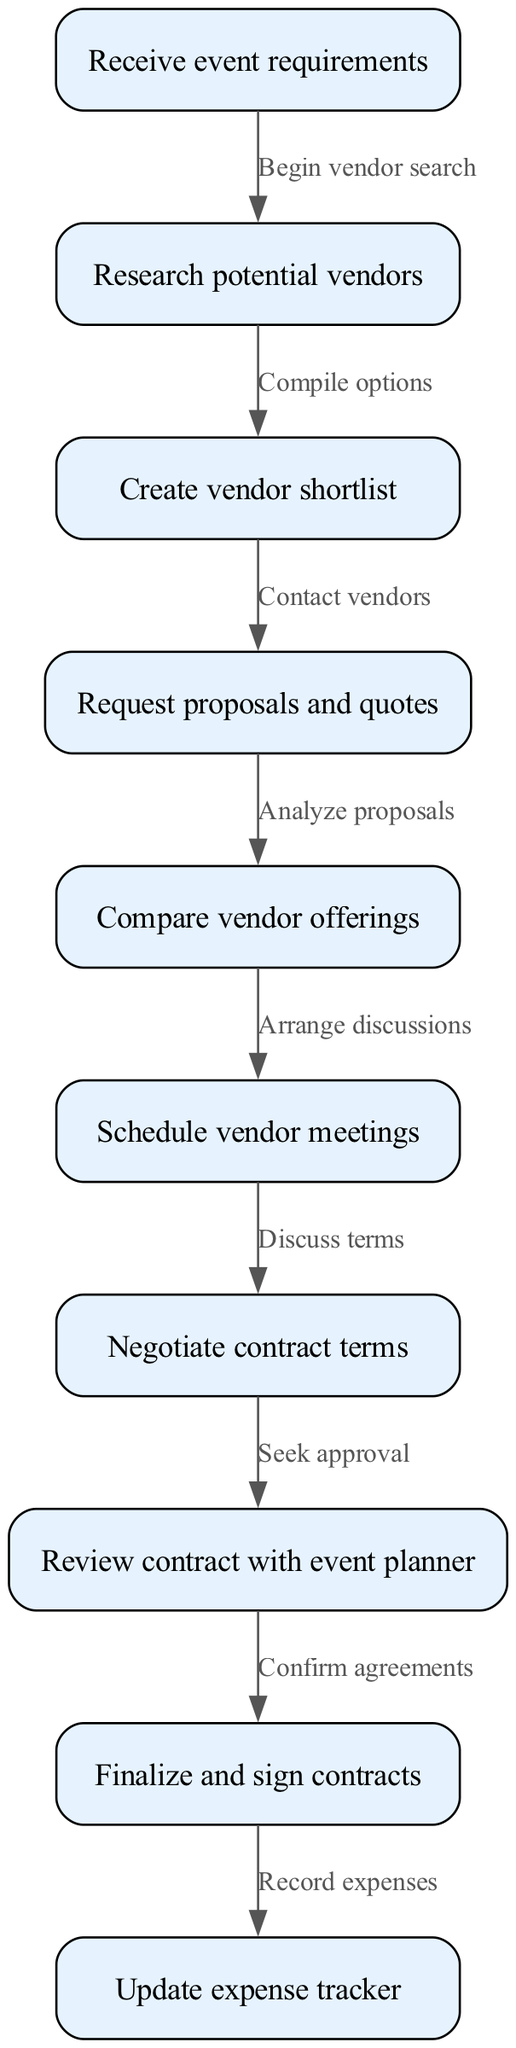What is the first step in the vendor selection workflow? The first step in the workflow is represented by the node labeled "Receive event requirements". This indicates that gathering the event specifics is the initial action before any vendor-related activities begin.
Answer: Receive event requirements How many nodes are in the diagram? By counting the individual nodes listed in the data, we can see there are 10 distinct steps involved in the vendor selection and contract negotiation workflow.
Answer: 10 Which node follows "Request proposals and quotes"? After analyzing the proposals at the "Request proposals and quotes" node, the next node is "Compare vendor offerings". This indicates that the review process continues with comparing the various proposals received.
Answer: Compare vendor offerings What connects "Negotiate contract terms" and "Review contract with event planner"? The connection between "Negotiate contract terms" and "Review contract with event planner" is labeled "Seek approval". This signifies that after negotiating, the next step involves obtaining approval on the negotiated terms from the event planner.
Answer: Seek approval What is the final action in the workflow? The last action in the vendor selection and contract negotiation workflow is "Update expense tracker". This indicates that after all contracts are signed, the final step is to ensure that all related expenses are recorded accurately.
Answer: Update expense tracker What is the relationship between "Research potential vendors" and "Create vendor shortlist"? The relationship is described by the edge labeled "Compile options". It shows that researching vendors leads directly to compiling a shortlist based on the findings from that research.
Answer: Compile options How many edges are present in the diagram? By reviewing the connections between the nodes, it is found that there are 9 edges that represent the flow of actions between the different steps in the workflow.
Answer: 9 Which node precedes "Finalize and sign contracts"? The node that comes just before "Finalize and sign contracts" is "Review contract with event planner". This indicates that reviewing the contract with the event planner is a prerequisite step before finalizing and signing the contracts.
Answer: Review contract with event planner 